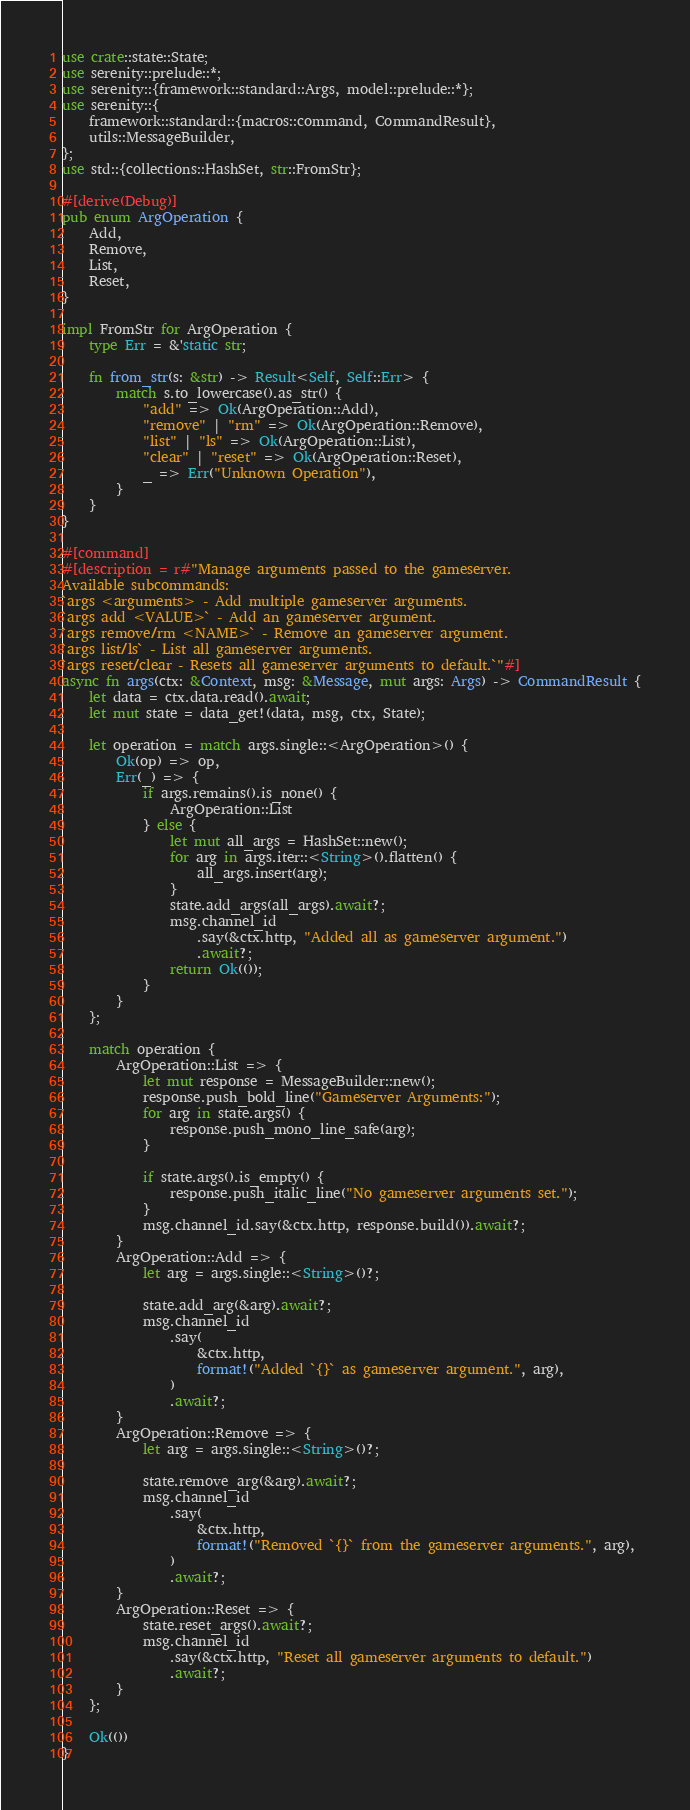Convert code to text. <code><loc_0><loc_0><loc_500><loc_500><_Rust_>use crate::state::State;
use serenity::prelude::*;
use serenity::{framework::standard::Args, model::prelude::*};
use serenity::{
    framework::standard::{macros::command, CommandResult},
    utils::MessageBuilder,
};
use std::{collections::HashSet, str::FromStr};

#[derive(Debug)]
pub enum ArgOperation {
    Add,
    Remove,
    List,
    Reset,
}

impl FromStr for ArgOperation {
    type Err = &'static str;

    fn from_str(s: &str) -> Result<Self, Self::Err> {
        match s.to_lowercase().as_str() {
            "add" => Ok(ArgOperation::Add),
            "remove" | "rm" => Ok(ArgOperation::Remove),
            "list" | "ls" => Ok(ArgOperation::List),
            "clear" | "reset" => Ok(ArgOperation::Reset),
            _ => Err("Unknown Operation"),
        }
    }
}

#[command]
#[description = r#"Manage arguments passed to the gameserver.
Available subcommands:
`args <arguments> - Add multiple gameserver arguments.
`args add <VALUE>` - Add an gameserver argument.
`args remove/rm <NAME>` - Remove an gameserver argument.
`args list/ls` - List all gameserver arguments.
`args reset/clear - Resets all gameserver arguments to default.`"#]
async fn args(ctx: &Context, msg: &Message, mut args: Args) -> CommandResult {
    let data = ctx.data.read().await;
    let mut state = data_get!(data, msg, ctx, State);

    let operation = match args.single::<ArgOperation>() {
        Ok(op) => op,
        Err(_) => {
            if args.remains().is_none() {
                ArgOperation::List
            } else {
                let mut all_args = HashSet::new();
                for arg in args.iter::<String>().flatten() {
                    all_args.insert(arg);
                }
                state.add_args(all_args).await?;
                msg.channel_id
                    .say(&ctx.http, "Added all as gameserver argument.")
                    .await?;
                return Ok(());
            }
        }
    };

    match operation {
        ArgOperation::List => {
            let mut response = MessageBuilder::new();
            response.push_bold_line("Gameserver Arguments:");
            for arg in state.args() {
                response.push_mono_line_safe(arg);
            }

            if state.args().is_empty() {
                response.push_italic_line("No gameserver arguments set.");
            }
            msg.channel_id.say(&ctx.http, response.build()).await?;
        }
        ArgOperation::Add => {
            let arg = args.single::<String>()?;

            state.add_arg(&arg).await?;
            msg.channel_id
                .say(
                    &ctx.http,
                    format!("Added `{}` as gameserver argument.", arg),
                )
                .await?;
        }
        ArgOperation::Remove => {
            let arg = args.single::<String>()?;

            state.remove_arg(&arg).await?;
            msg.channel_id
                .say(
                    &ctx.http,
                    format!("Removed `{}` from the gameserver arguments.", arg),
                )
                .await?;
        }
        ArgOperation::Reset => {
            state.reset_args().await?;
            msg.channel_id
                .say(&ctx.http, "Reset all gameserver arguments to default.")
                .await?;
        }
    };

    Ok(())
}
</code> 